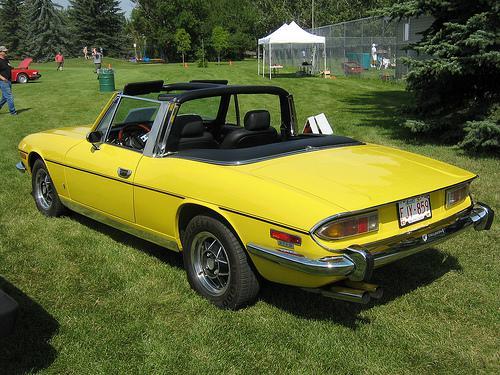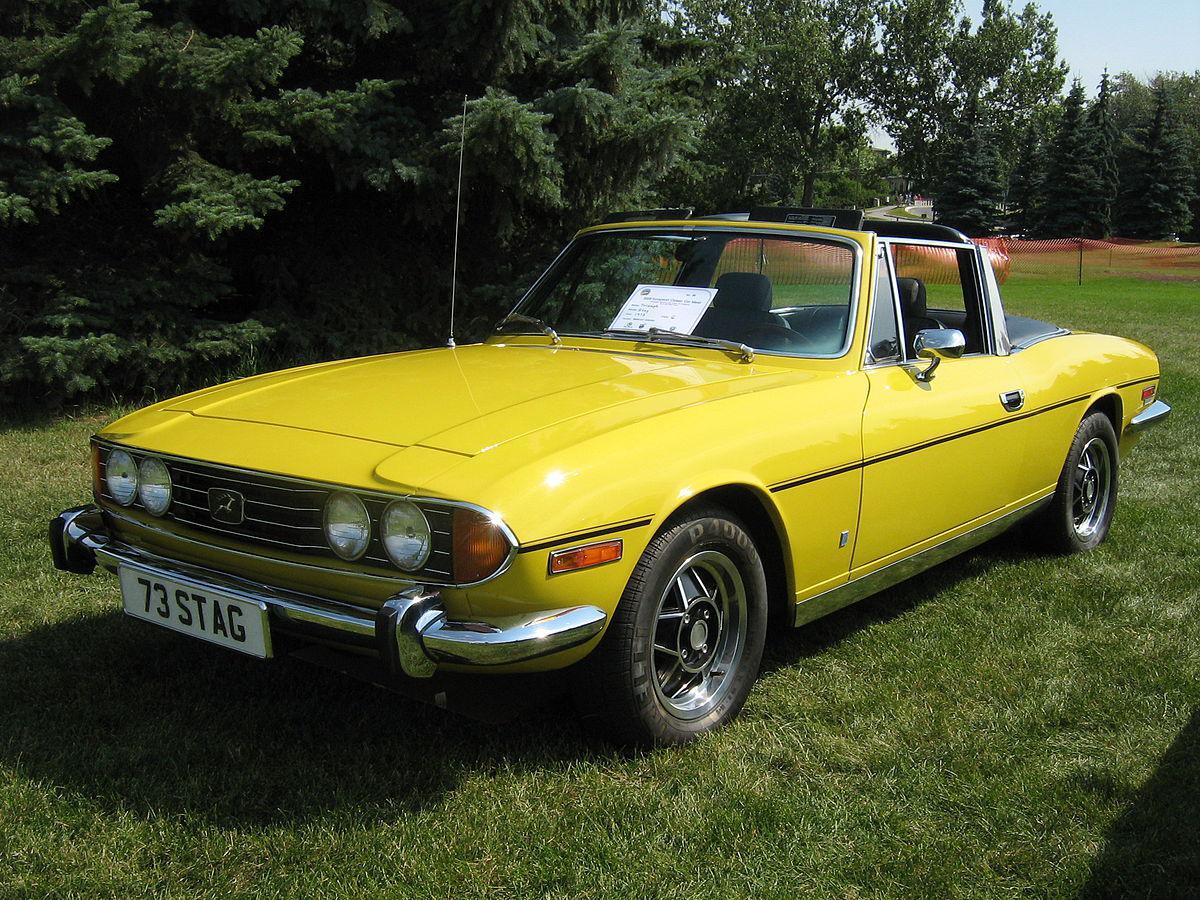The first image is the image on the left, the second image is the image on the right. Analyze the images presented: Is the assertion "There are two yellow cars parked on grass." valid? Answer yes or no. Yes. The first image is the image on the left, the second image is the image on the right. For the images displayed, is the sentence "An image shows a horizontal parked red convertible with its black top covering it." factually correct? Answer yes or no. No. 